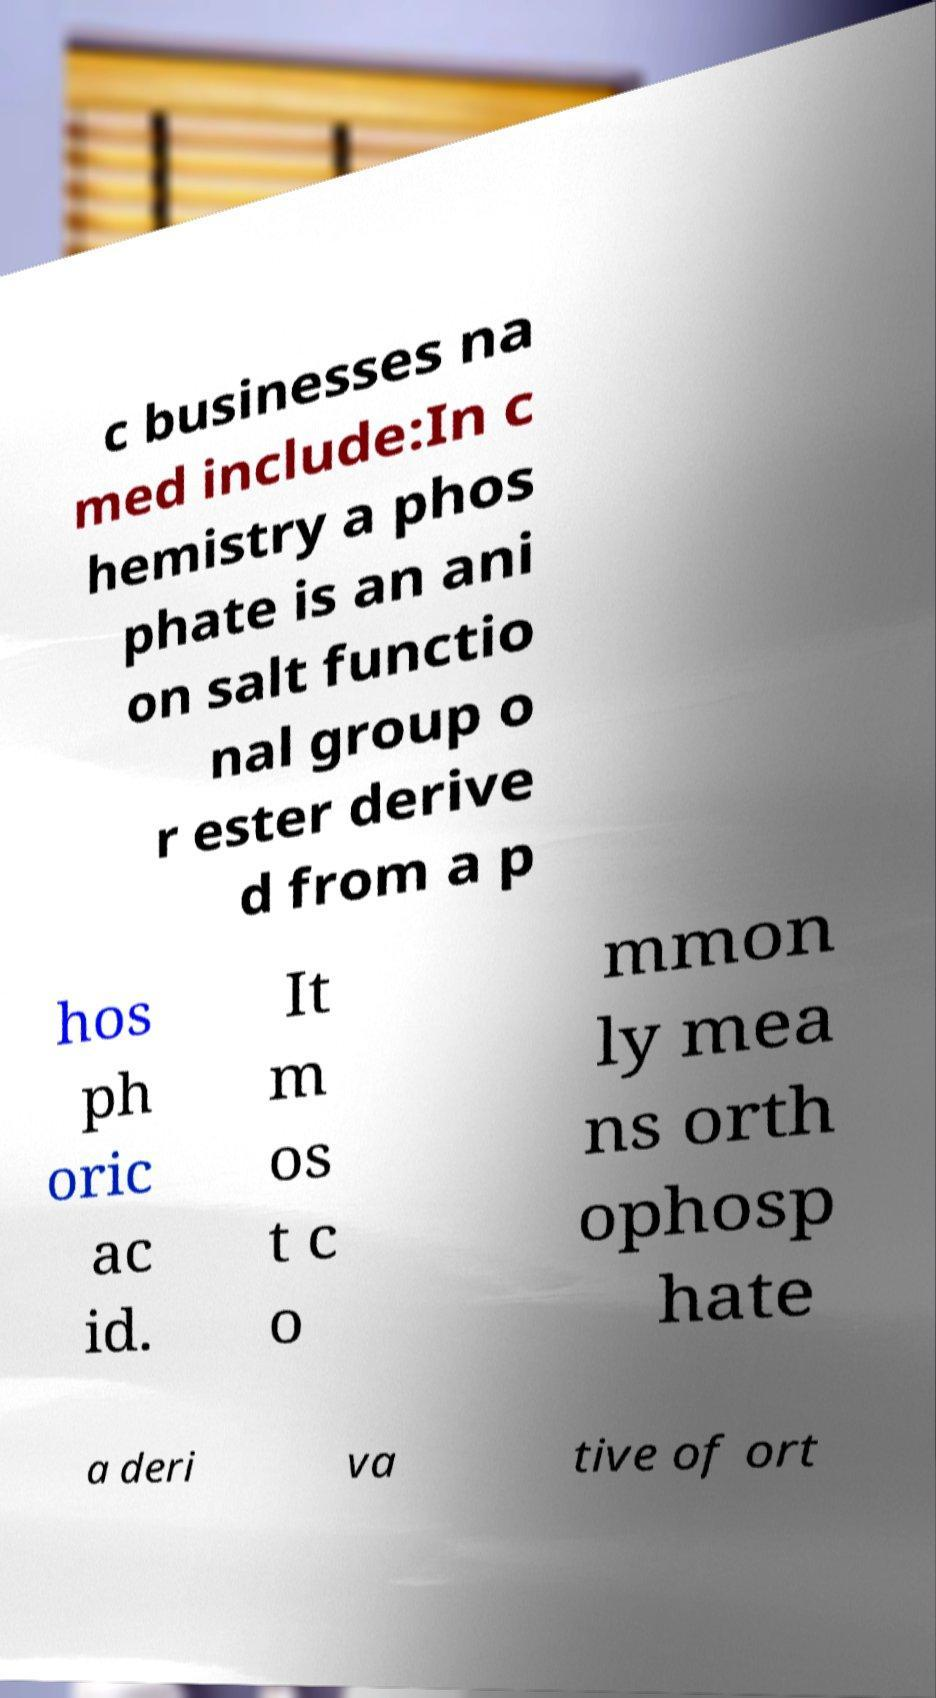Can you accurately transcribe the text from the provided image for me? c businesses na med include:In c hemistry a phos phate is an ani on salt functio nal group o r ester derive d from a p hos ph oric ac id. It m os t c o mmon ly mea ns orth ophosp hate a deri va tive of ort 